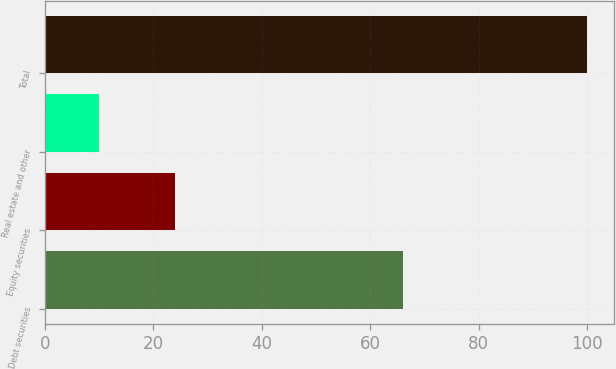<chart> <loc_0><loc_0><loc_500><loc_500><bar_chart><fcel>Debt securities<fcel>Equity securities<fcel>Real estate and other<fcel>Total<nl><fcel>66<fcel>24<fcel>10<fcel>100<nl></chart> 